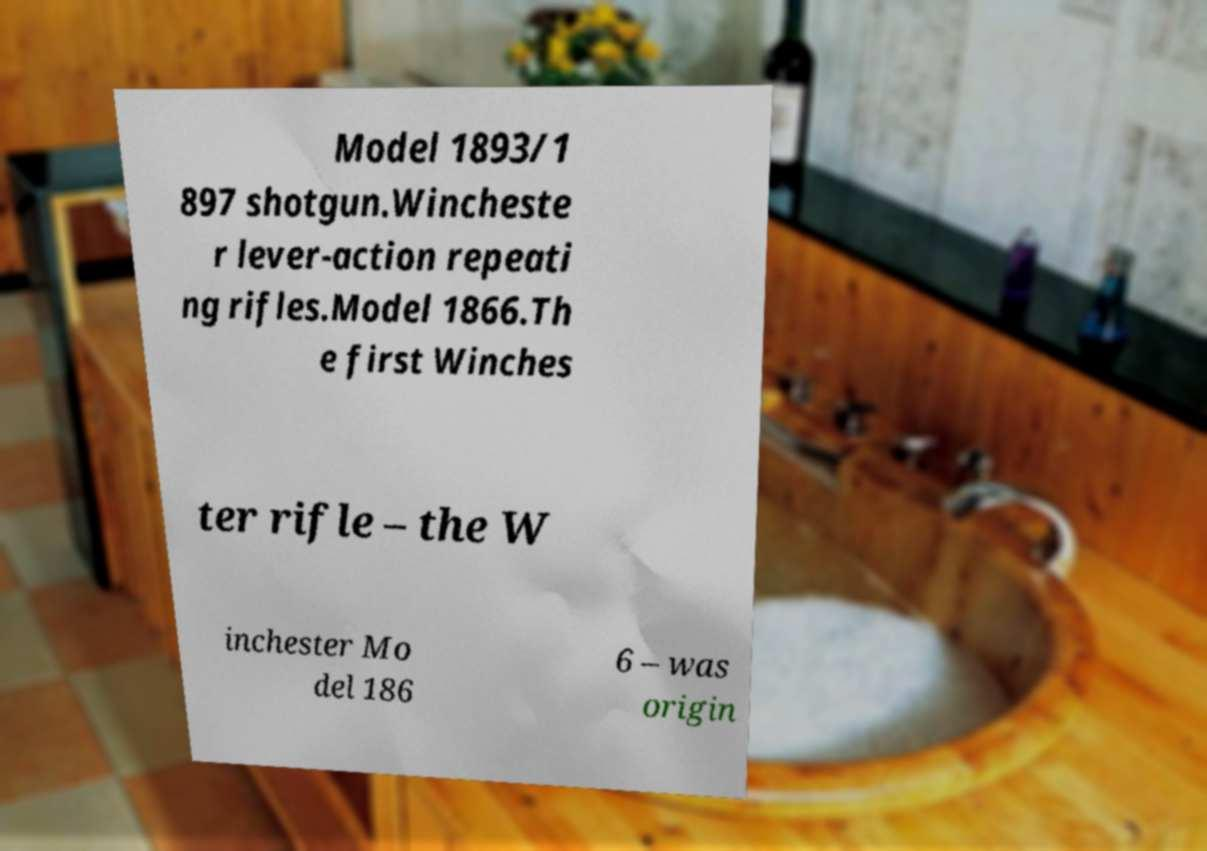Can you read and provide the text displayed in the image?This photo seems to have some interesting text. Can you extract and type it out for me? Model 1893/1 897 shotgun.Wincheste r lever-action repeati ng rifles.Model 1866.Th e first Winches ter rifle – the W inchester Mo del 186 6 – was origin 